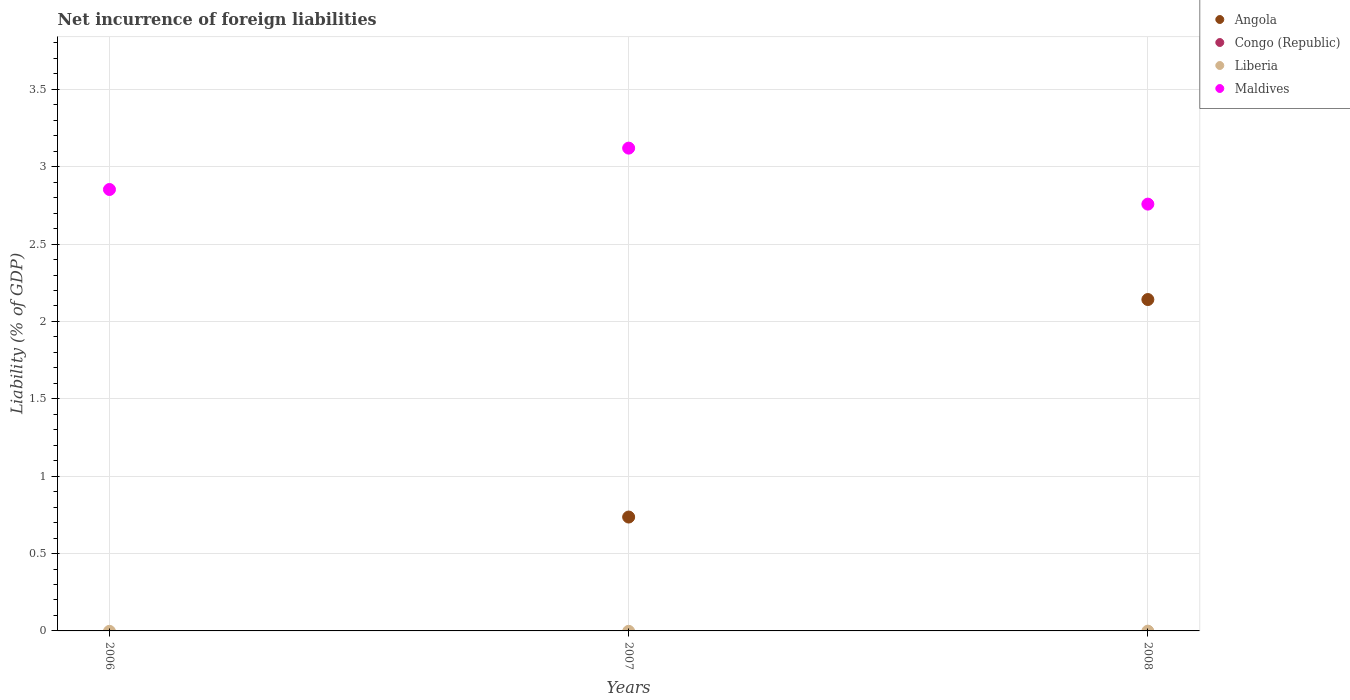Is the number of dotlines equal to the number of legend labels?
Your answer should be very brief. No. What is the net incurrence of foreign liabilities in Congo (Republic) in 2008?
Your response must be concise. 0. Across all years, what is the maximum net incurrence of foreign liabilities in Angola?
Provide a short and direct response. 2.14. Across all years, what is the minimum net incurrence of foreign liabilities in Maldives?
Your answer should be very brief. 2.76. What is the total net incurrence of foreign liabilities in Congo (Republic) in the graph?
Offer a very short reply. 0. What is the difference between the net incurrence of foreign liabilities in Maldives in 2007 and that in 2008?
Offer a very short reply. 0.36. What is the average net incurrence of foreign liabilities in Angola per year?
Your response must be concise. 0.96. In the year 2007, what is the difference between the net incurrence of foreign liabilities in Maldives and net incurrence of foreign liabilities in Angola?
Make the answer very short. 2.38. What is the ratio of the net incurrence of foreign liabilities in Maldives in 2006 to that in 2007?
Your response must be concise. 0.91. Is the net incurrence of foreign liabilities in Angola in 2007 less than that in 2008?
Provide a succinct answer. Yes. What is the difference between the highest and the second highest net incurrence of foreign liabilities in Maldives?
Offer a terse response. 0.27. What is the difference between the highest and the lowest net incurrence of foreign liabilities in Maldives?
Your answer should be compact. 0.36. In how many years, is the net incurrence of foreign liabilities in Liberia greater than the average net incurrence of foreign liabilities in Liberia taken over all years?
Provide a short and direct response. 0. Is the sum of the net incurrence of foreign liabilities in Maldives in 2006 and 2008 greater than the maximum net incurrence of foreign liabilities in Angola across all years?
Your answer should be very brief. Yes. Is it the case that in every year, the sum of the net incurrence of foreign liabilities in Congo (Republic) and net incurrence of foreign liabilities in Liberia  is greater than the net incurrence of foreign liabilities in Angola?
Your response must be concise. No. Is the net incurrence of foreign liabilities in Congo (Republic) strictly greater than the net incurrence of foreign liabilities in Maldives over the years?
Provide a short and direct response. No. What is the difference between two consecutive major ticks on the Y-axis?
Keep it short and to the point. 0.5. Are the values on the major ticks of Y-axis written in scientific E-notation?
Make the answer very short. No. How many legend labels are there?
Offer a very short reply. 4. What is the title of the graph?
Make the answer very short. Net incurrence of foreign liabilities. Does "Turkey" appear as one of the legend labels in the graph?
Your answer should be compact. No. What is the label or title of the X-axis?
Make the answer very short. Years. What is the label or title of the Y-axis?
Your answer should be compact. Liability (% of GDP). What is the Liability (% of GDP) in Maldives in 2006?
Ensure brevity in your answer.  2.85. What is the Liability (% of GDP) of Angola in 2007?
Offer a terse response. 0.74. What is the Liability (% of GDP) in Liberia in 2007?
Offer a very short reply. 0. What is the Liability (% of GDP) in Maldives in 2007?
Your answer should be compact. 3.12. What is the Liability (% of GDP) of Angola in 2008?
Offer a terse response. 2.14. What is the Liability (% of GDP) in Maldives in 2008?
Your answer should be very brief. 2.76. Across all years, what is the maximum Liability (% of GDP) in Angola?
Keep it short and to the point. 2.14. Across all years, what is the maximum Liability (% of GDP) in Maldives?
Keep it short and to the point. 3.12. Across all years, what is the minimum Liability (% of GDP) in Maldives?
Give a very brief answer. 2.76. What is the total Liability (% of GDP) of Angola in the graph?
Make the answer very short. 2.88. What is the total Liability (% of GDP) of Liberia in the graph?
Provide a short and direct response. 0. What is the total Liability (% of GDP) of Maldives in the graph?
Your answer should be very brief. 8.73. What is the difference between the Liability (% of GDP) in Maldives in 2006 and that in 2007?
Ensure brevity in your answer.  -0.27. What is the difference between the Liability (% of GDP) in Maldives in 2006 and that in 2008?
Your response must be concise. 0.09. What is the difference between the Liability (% of GDP) in Angola in 2007 and that in 2008?
Make the answer very short. -1.41. What is the difference between the Liability (% of GDP) in Maldives in 2007 and that in 2008?
Your answer should be very brief. 0.36. What is the difference between the Liability (% of GDP) in Angola in 2007 and the Liability (% of GDP) in Maldives in 2008?
Your answer should be compact. -2.02. What is the average Liability (% of GDP) in Angola per year?
Ensure brevity in your answer.  0.96. What is the average Liability (% of GDP) in Liberia per year?
Provide a succinct answer. 0. What is the average Liability (% of GDP) in Maldives per year?
Offer a very short reply. 2.91. In the year 2007, what is the difference between the Liability (% of GDP) of Angola and Liability (% of GDP) of Maldives?
Ensure brevity in your answer.  -2.38. In the year 2008, what is the difference between the Liability (% of GDP) in Angola and Liability (% of GDP) in Maldives?
Keep it short and to the point. -0.62. What is the ratio of the Liability (% of GDP) of Maldives in 2006 to that in 2007?
Give a very brief answer. 0.91. What is the ratio of the Liability (% of GDP) of Maldives in 2006 to that in 2008?
Keep it short and to the point. 1.03. What is the ratio of the Liability (% of GDP) in Angola in 2007 to that in 2008?
Your response must be concise. 0.34. What is the ratio of the Liability (% of GDP) of Maldives in 2007 to that in 2008?
Your response must be concise. 1.13. What is the difference between the highest and the second highest Liability (% of GDP) in Maldives?
Your answer should be very brief. 0.27. What is the difference between the highest and the lowest Liability (% of GDP) in Angola?
Your answer should be very brief. 2.14. What is the difference between the highest and the lowest Liability (% of GDP) of Maldives?
Your response must be concise. 0.36. 